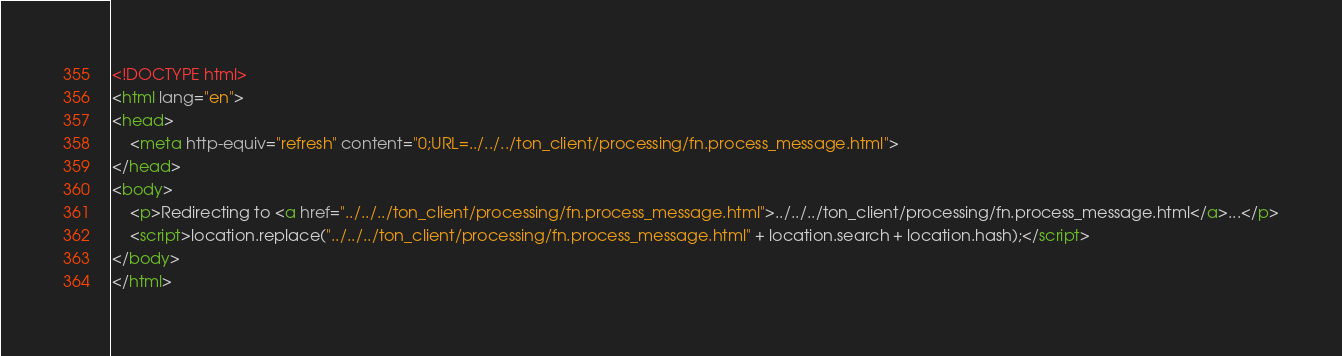Convert code to text. <code><loc_0><loc_0><loc_500><loc_500><_HTML_><!DOCTYPE html>
<html lang="en">
<head>
    <meta http-equiv="refresh" content="0;URL=../../../ton_client/processing/fn.process_message.html">
</head>
<body>
    <p>Redirecting to <a href="../../../ton_client/processing/fn.process_message.html">../../../ton_client/processing/fn.process_message.html</a>...</p>
    <script>location.replace("../../../ton_client/processing/fn.process_message.html" + location.search + location.hash);</script>
</body>
</html></code> 